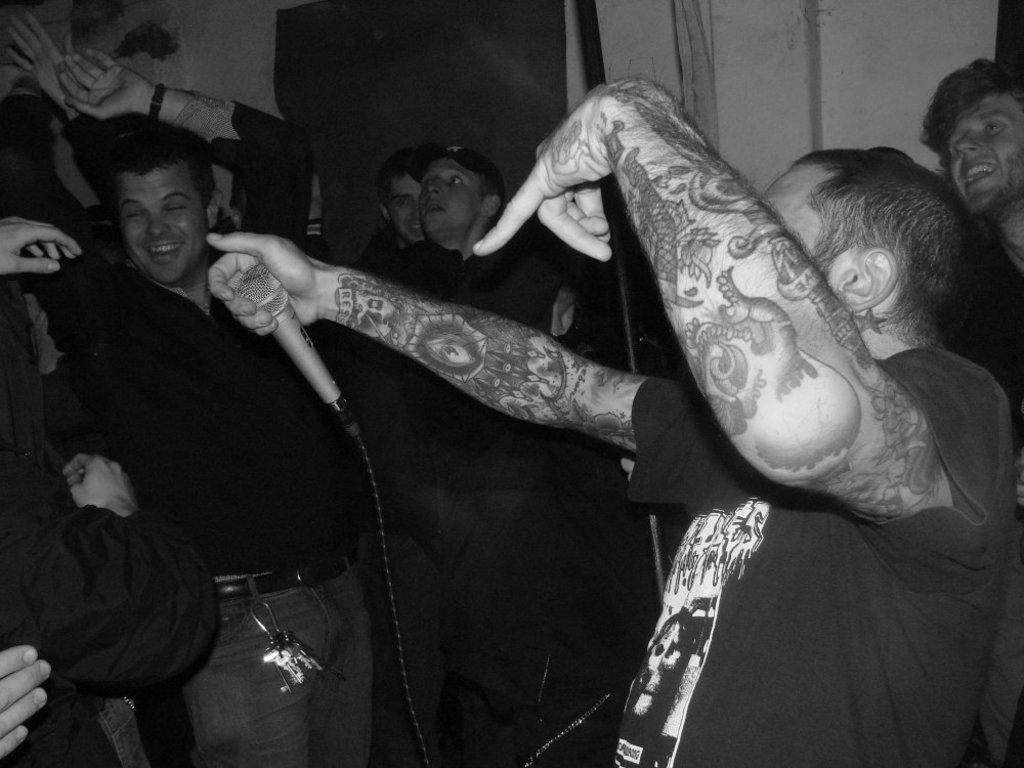Describe this image in one or two sentences. In this image there are a few people dancing with a smile on their face, one of them is holding a mic in his hand. In the background there is a wall. 